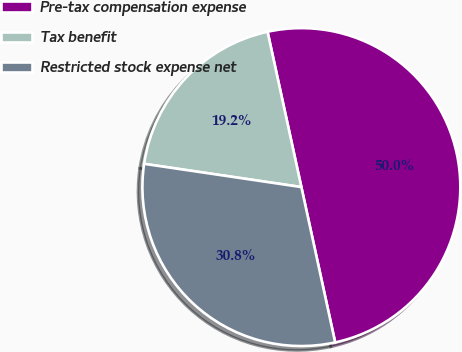Convert chart. <chart><loc_0><loc_0><loc_500><loc_500><pie_chart><fcel>Pre-tax compensation expense<fcel>Tax benefit<fcel>Restricted stock expense net<nl><fcel>50.0%<fcel>19.25%<fcel>30.75%<nl></chart> 